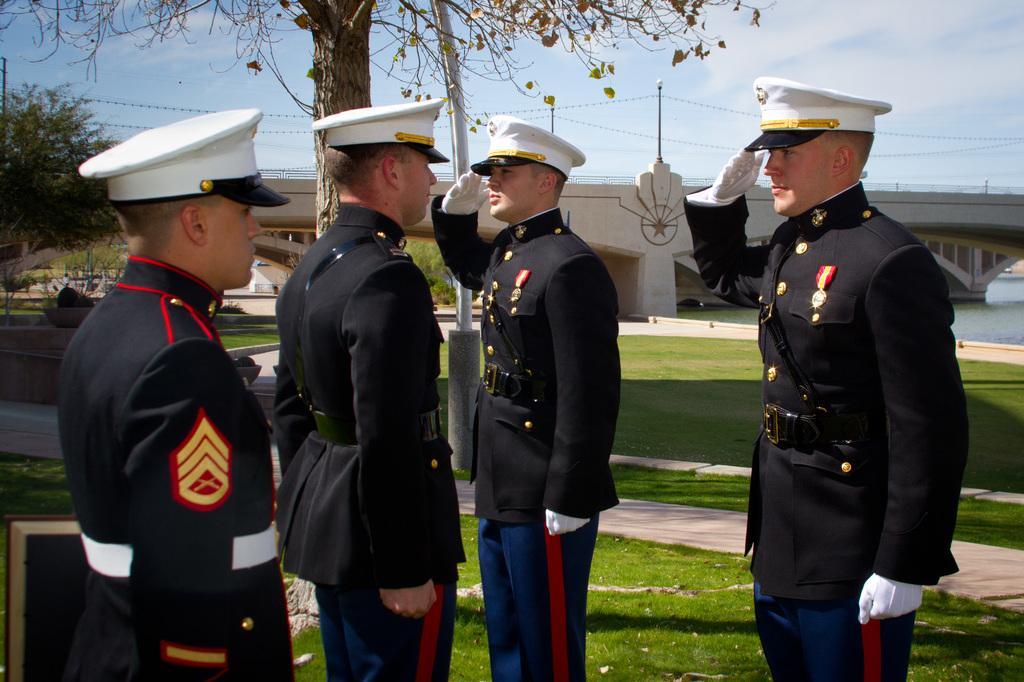Could you give a brief overview of what you see in this image? This picture is clicked outside. In the foreground we can see the group of persons wearing uniforms and standing. We can see the green grass, trees, sky, lights attached to the poles and a water body and the bridge and some other items. 